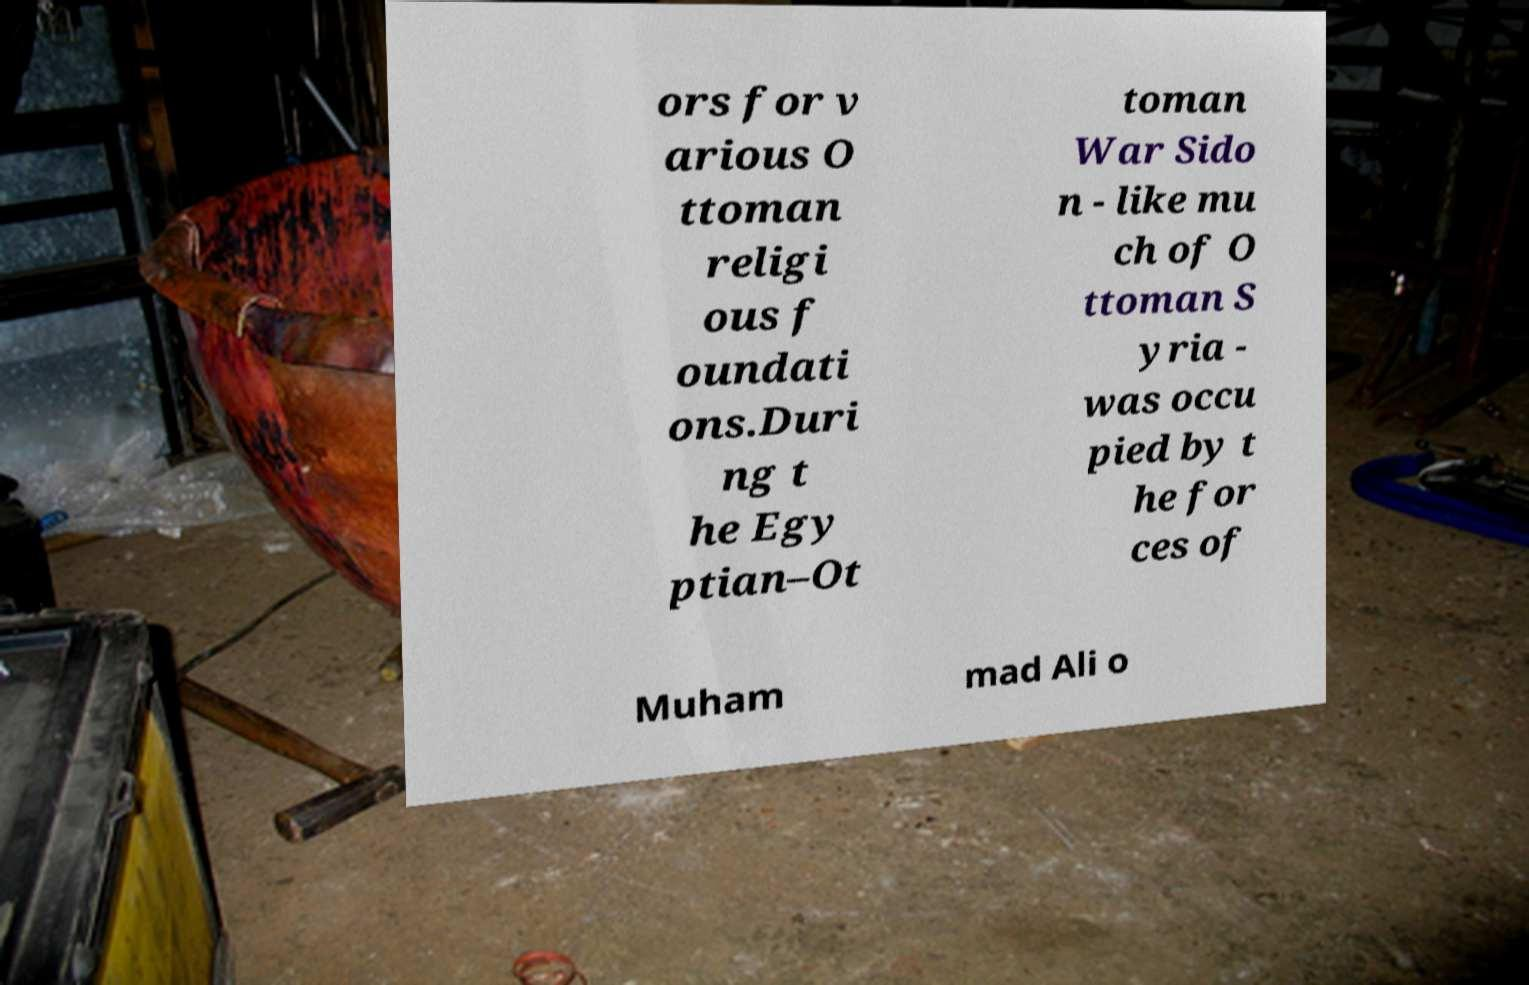I need the written content from this picture converted into text. Can you do that? ors for v arious O ttoman religi ous f oundati ons.Duri ng t he Egy ptian–Ot toman War Sido n - like mu ch of O ttoman S yria - was occu pied by t he for ces of Muham mad Ali o 